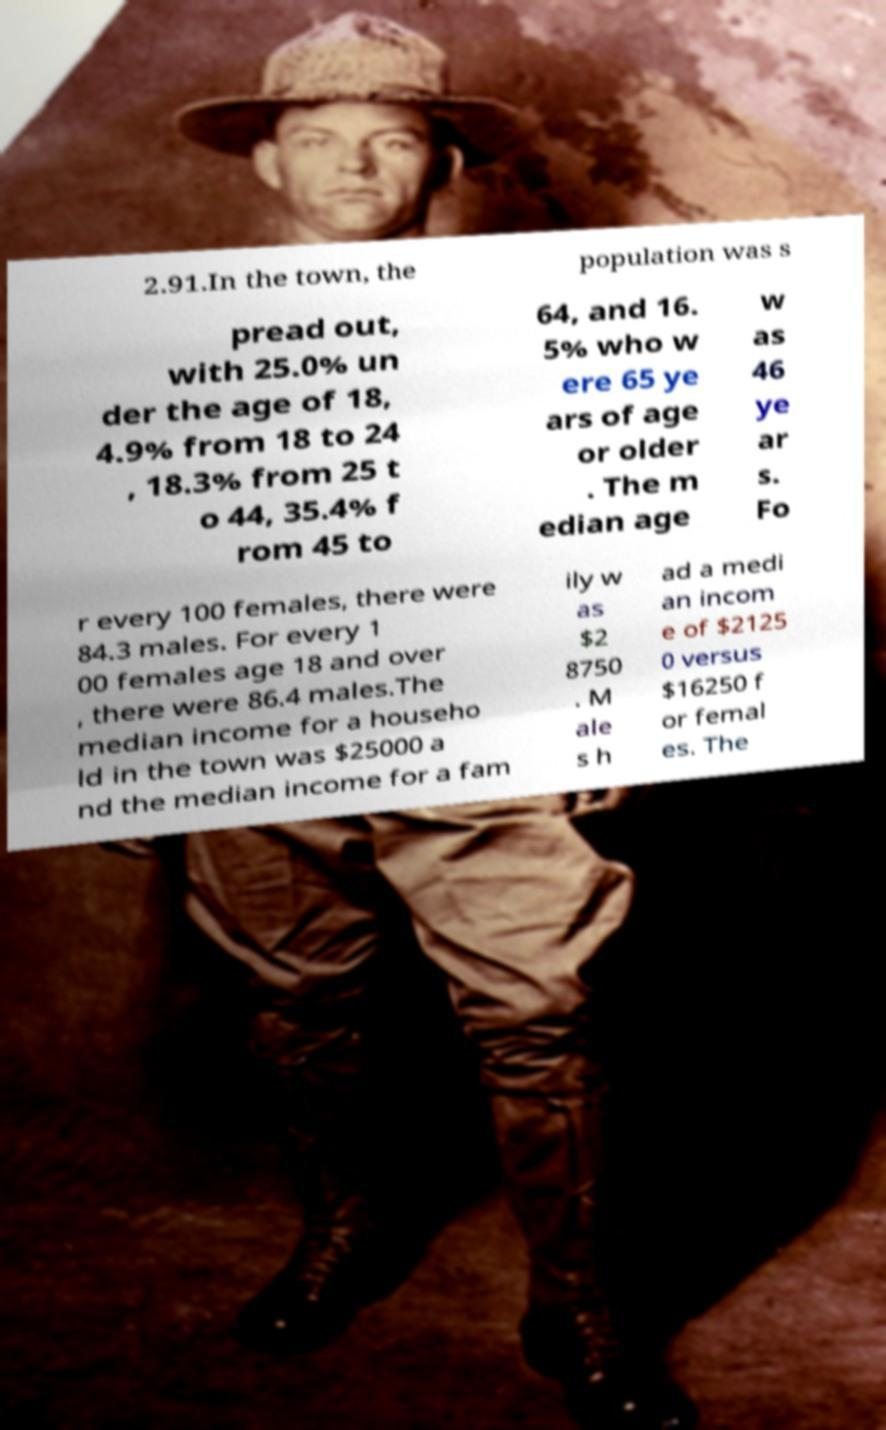Please identify and transcribe the text found in this image. 2.91.In the town, the population was s pread out, with 25.0% un der the age of 18, 4.9% from 18 to 24 , 18.3% from 25 t o 44, 35.4% f rom 45 to 64, and 16. 5% who w ere 65 ye ars of age or older . The m edian age w as 46 ye ar s. Fo r every 100 females, there were 84.3 males. For every 1 00 females age 18 and over , there were 86.4 males.The median income for a househo ld in the town was $25000 a nd the median income for a fam ily w as $2 8750 . M ale s h ad a medi an incom e of $2125 0 versus $16250 f or femal es. The 